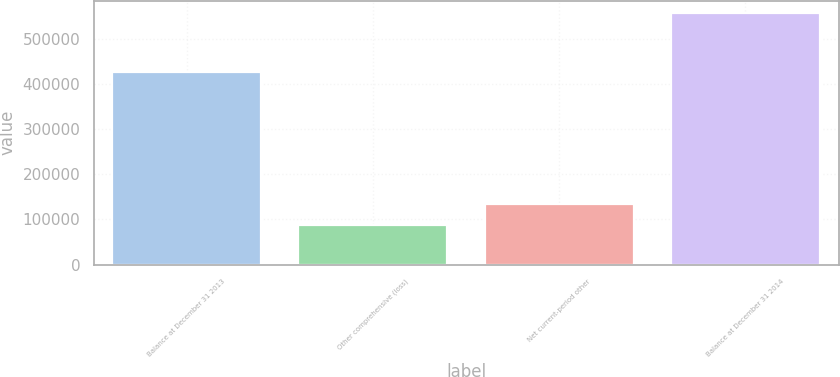Convert chart to OTSL. <chart><loc_0><loc_0><loc_500><loc_500><bar_chart><fcel>Balance at December 31 2013<fcel>Other comprehensive (loss)<fcel>Net current-period other<fcel>Balance at December 31 2014<nl><fcel>426830<fcel>88088<fcel>134856<fcel>555767<nl></chart> 